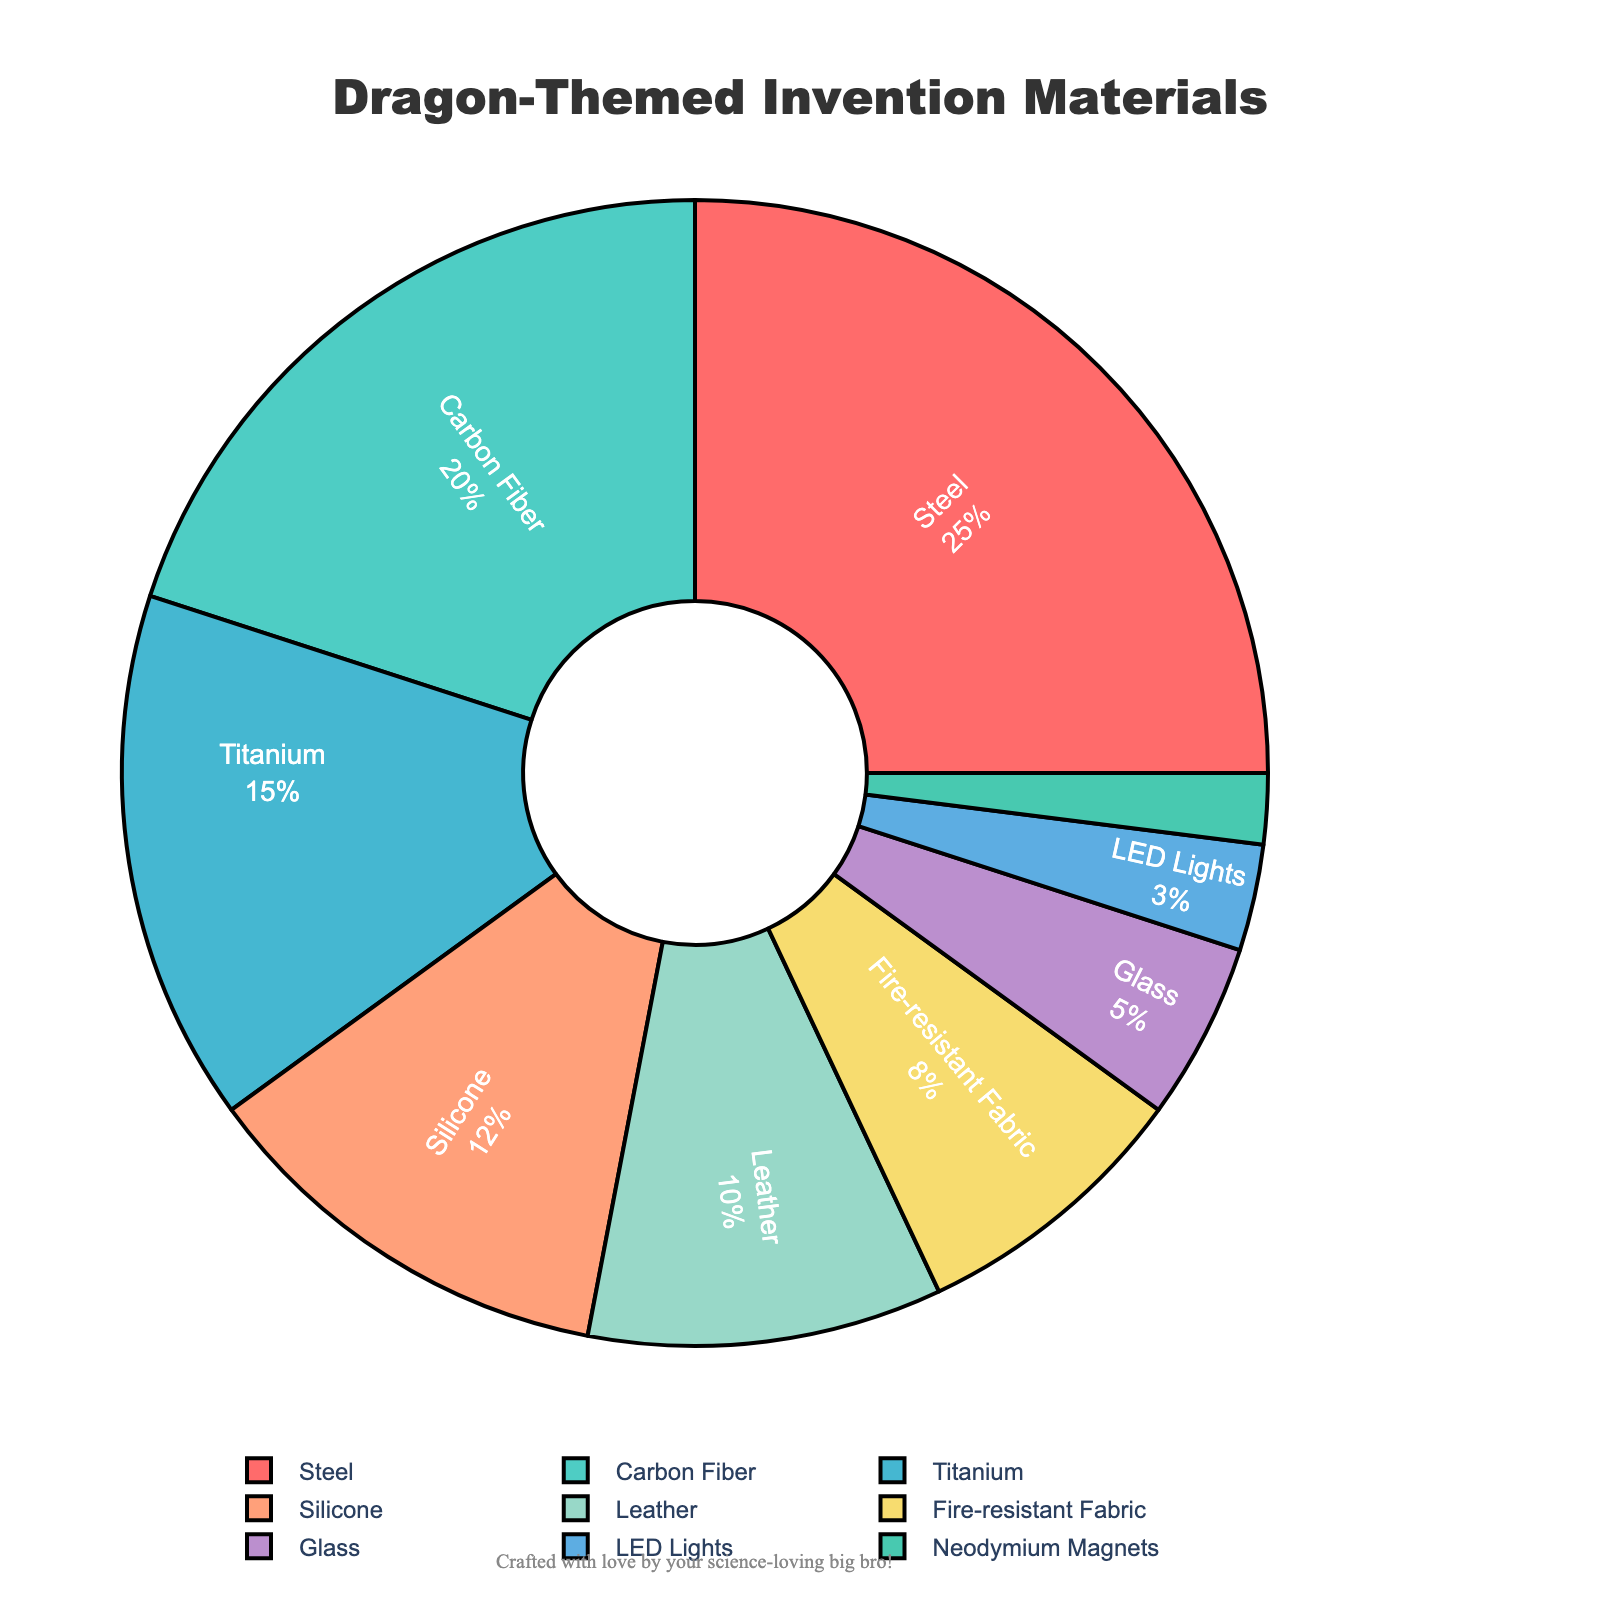What material is used the most in dragon-themed inventions? The largest section of the pie chart indicates the most used material. The material labeled "Steel" occupies the largest portion, accounting for 25%.
Answer: Steel Which materials together make up half of the total materials used? To make half the total, add the percentages of the largest materials until you reach 50%. Steel (25%) + Carbon Fiber (20%) + Titanium (15%) = 60%. Removing Titanium (15%) gives 45% with Steel and Carbon Fiber only, so we need parts of multiple groups. Therefore, Steel, Carbon Fiber, and Titanium combined exceed half of the total.
Answer: Steel, Carbon Fiber, Titanium How does the percentage of Silicone compare to that of Leather? The chart shows that Silicone is 12% and Leather is 10%. Compare these values directly.
Answer: Silicone is 2% higher than Leather What is the combined percentage of materials that are used less than 10%? Identify percentages for all materials less than 10%: Fire-resistant Fabric (8%), Glass (5%), LED Lights (3%), Neodymium Magnets (2%). Add these values together: 8% + 5% + 3% + 2% = 18%.
Answer: 18% What percent of the total is made up by the most common material and the least common material together? Identify the most and least common materials in the chart: Steel (25%) and Neodymium Magnets (2%). Add their percentages: 25% + 2% = 27%.
Answer: 27% Which material is represented in blue in the chart? By examining the chart visually, locate the slice colored blue, which is labeled "Titanium" and corresponds to 15%.
Answer: Titanium How much larger is the percentage of Steel compared to Carbon Fiber? Identify percentages for Steel (25%) and Carbon Fiber (20%) and subtract: 25% - 20% = 5%.
Answer: 5% Name two materials whose combined percentages equal the percentage of Steel. Identify potential pairs whose sums equal Steel's 25%. Leather (10%) + Fire-resistant Fabric (8%) + Silicone (12%) = 30%. The exact pair is ~Titanium (15%) + Silicone (12%) = 27%, hence challenging the possibility of exact pairs, none exist.
Answer: None Which three materials together make up approximately one-third of the total materials? Calculate approximately one-third of 100%, which is ~33.3%. Try combining materials: Titanium (15%) + Leather (10%) + Fire-resistant Fabric (8%) = 33%. This combination equals approximately one-third.
Answer: Titanium, Leather, Fire-resistant Fabric If LED Lights and Neodymium Magnets are removed, what percentage of the total materials is left? Identify percentages for LED Lights (3%) and Neodymium Magnets (2%), sum them: 3% + 2% = 5%. Subtract this from the total (100%): 100% - 5% = 95%.
Answer: 95% 